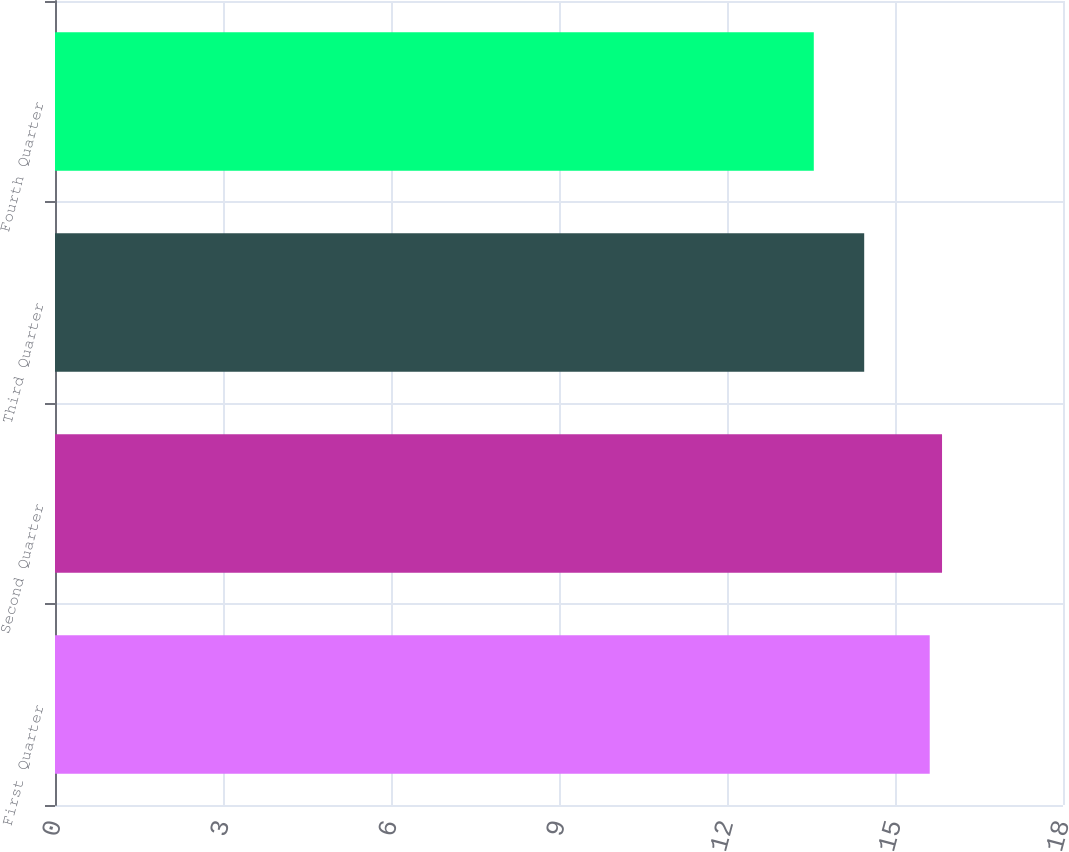Convert chart to OTSL. <chart><loc_0><loc_0><loc_500><loc_500><bar_chart><fcel>First Quarter<fcel>Second Quarter<fcel>Third Quarter<fcel>Fourth Quarter<nl><fcel>15.62<fcel>15.84<fcel>14.45<fcel>13.55<nl></chart> 